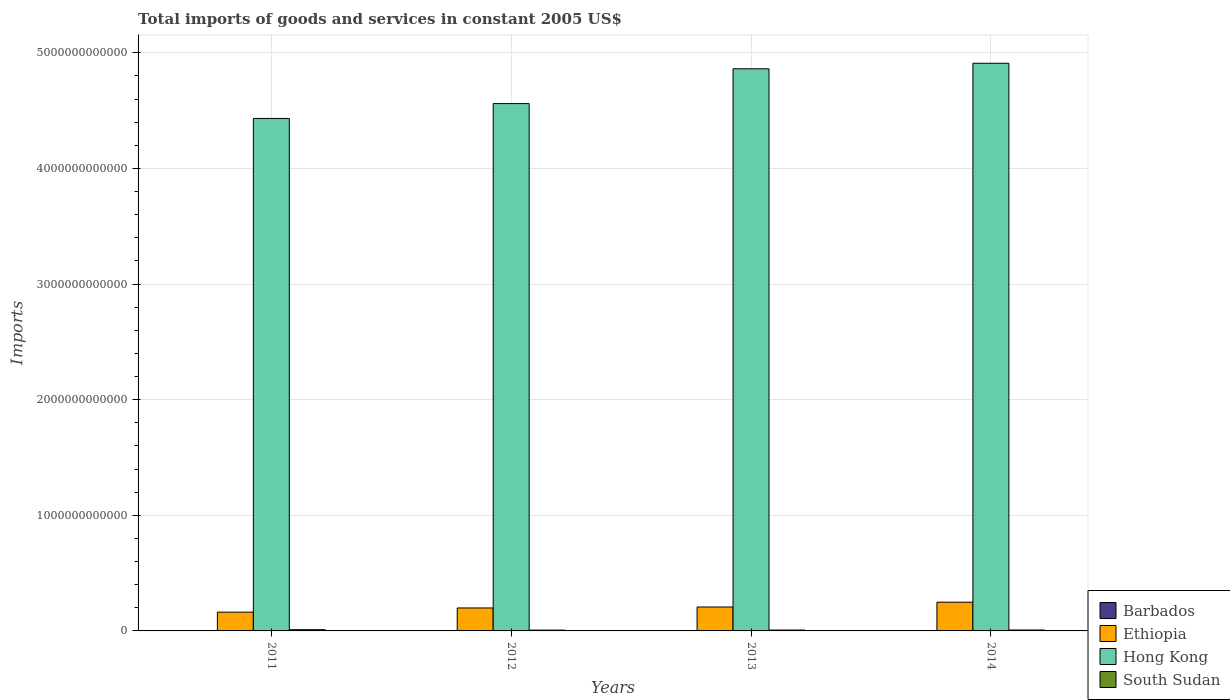How many different coloured bars are there?
Ensure brevity in your answer.  4. How many groups of bars are there?
Give a very brief answer. 4. Are the number of bars on each tick of the X-axis equal?
Ensure brevity in your answer.  Yes. What is the total imports of goods and services in Barbados in 2013?
Offer a terse response. 5.64e+08. Across all years, what is the maximum total imports of goods and services in Hong Kong?
Offer a terse response. 4.91e+12. Across all years, what is the minimum total imports of goods and services in Hong Kong?
Your answer should be very brief. 4.43e+12. What is the total total imports of goods and services in South Sudan in the graph?
Provide a succinct answer. 3.33e+1. What is the difference between the total imports of goods and services in South Sudan in 2012 and that in 2014?
Provide a succinct answer. -1.13e+09. What is the difference between the total imports of goods and services in Hong Kong in 2011 and the total imports of goods and services in Barbados in 2013?
Keep it short and to the point. 4.43e+12. What is the average total imports of goods and services in Barbados per year?
Your response must be concise. 5.76e+08. In the year 2011, what is the difference between the total imports of goods and services in Hong Kong and total imports of goods and services in Ethiopia?
Provide a short and direct response. 4.27e+12. What is the ratio of the total imports of goods and services in Barbados in 2011 to that in 2014?
Your answer should be very brief. 1.04. Is the total imports of goods and services in Ethiopia in 2011 less than that in 2013?
Provide a short and direct response. Yes. What is the difference between the highest and the second highest total imports of goods and services in South Sudan?
Make the answer very short. 2.64e+09. What is the difference between the highest and the lowest total imports of goods and services in Hong Kong?
Your answer should be compact. 4.77e+11. In how many years, is the total imports of goods and services in Barbados greater than the average total imports of goods and services in Barbados taken over all years?
Give a very brief answer. 1. Is the sum of the total imports of goods and services in Ethiopia in 2011 and 2014 greater than the maximum total imports of goods and services in South Sudan across all years?
Give a very brief answer. Yes. What does the 4th bar from the left in 2014 represents?
Provide a succinct answer. South Sudan. What does the 3rd bar from the right in 2012 represents?
Your answer should be compact. Ethiopia. How many bars are there?
Make the answer very short. 16. How many years are there in the graph?
Keep it short and to the point. 4. What is the difference between two consecutive major ticks on the Y-axis?
Make the answer very short. 1.00e+12. Does the graph contain grids?
Provide a short and direct response. Yes. What is the title of the graph?
Make the answer very short. Total imports of goods and services in constant 2005 US$. What is the label or title of the Y-axis?
Ensure brevity in your answer.  Imports. What is the Imports of Barbados in 2011?
Keep it short and to the point. 5.96e+08. What is the Imports of Ethiopia in 2011?
Make the answer very short. 1.62e+11. What is the Imports of Hong Kong in 2011?
Make the answer very short. 4.43e+12. What is the Imports in South Sudan in 2011?
Offer a very short reply. 1.07e+1. What is the Imports in Barbados in 2012?
Keep it short and to the point. 5.68e+08. What is the Imports in Ethiopia in 2012?
Keep it short and to the point. 1.99e+11. What is the Imports in Hong Kong in 2012?
Provide a short and direct response. 4.56e+12. What is the Imports of South Sudan in 2012?
Give a very brief answer. 6.91e+09. What is the Imports of Barbados in 2013?
Offer a very short reply. 5.64e+08. What is the Imports in Ethiopia in 2013?
Your answer should be compact. 2.07e+11. What is the Imports in Hong Kong in 2013?
Offer a very short reply. 4.86e+12. What is the Imports of South Sudan in 2013?
Make the answer very short. 7.65e+09. What is the Imports of Barbados in 2014?
Your answer should be very brief. 5.75e+08. What is the Imports of Ethiopia in 2014?
Your answer should be very brief. 2.49e+11. What is the Imports of Hong Kong in 2014?
Your answer should be compact. 4.91e+12. What is the Imports of South Sudan in 2014?
Your response must be concise. 8.04e+09. Across all years, what is the maximum Imports in Barbados?
Your answer should be compact. 5.96e+08. Across all years, what is the maximum Imports in Ethiopia?
Provide a succinct answer. 2.49e+11. Across all years, what is the maximum Imports of Hong Kong?
Keep it short and to the point. 4.91e+12. Across all years, what is the maximum Imports of South Sudan?
Make the answer very short. 1.07e+1. Across all years, what is the minimum Imports in Barbados?
Your response must be concise. 5.64e+08. Across all years, what is the minimum Imports in Ethiopia?
Provide a succinct answer. 1.62e+11. Across all years, what is the minimum Imports in Hong Kong?
Make the answer very short. 4.43e+12. Across all years, what is the minimum Imports in South Sudan?
Offer a terse response. 6.91e+09. What is the total Imports in Barbados in the graph?
Your response must be concise. 2.30e+09. What is the total Imports of Ethiopia in the graph?
Provide a short and direct response. 8.17e+11. What is the total Imports of Hong Kong in the graph?
Your answer should be compact. 1.88e+13. What is the total Imports of South Sudan in the graph?
Your response must be concise. 3.33e+1. What is the difference between the Imports of Barbados in 2011 and that in 2012?
Offer a very short reply. 2.80e+07. What is the difference between the Imports of Ethiopia in 2011 and that in 2012?
Your answer should be very brief. -3.61e+1. What is the difference between the Imports of Hong Kong in 2011 and that in 2012?
Give a very brief answer. -1.29e+11. What is the difference between the Imports of South Sudan in 2011 and that in 2012?
Make the answer very short. 3.76e+09. What is the difference between the Imports in Barbados in 2011 and that in 2013?
Offer a terse response. 3.20e+07. What is the difference between the Imports of Ethiopia in 2011 and that in 2013?
Your answer should be very brief. -4.44e+1. What is the difference between the Imports of Hong Kong in 2011 and that in 2013?
Ensure brevity in your answer.  -4.30e+11. What is the difference between the Imports in South Sudan in 2011 and that in 2013?
Your answer should be very brief. 3.02e+09. What is the difference between the Imports in Barbados in 2011 and that in 2014?
Provide a succinct answer. 2.10e+07. What is the difference between the Imports of Ethiopia in 2011 and that in 2014?
Your answer should be compact. -8.62e+1. What is the difference between the Imports of Hong Kong in 2011 and that in 2014?
Your answer should be very brief. -4.77e+11. What is the difference between the Imports in South Sudan in 2011 and that in 2014?
Your answer should be very brief. 2.64e+09. What is the difference between the Imports in Ethiopia in 2012 and that in 2013?
Offer a very short reply. -8.37e+09. What is the difference between the Imports of Hong Kong in 2012 and that in 2013?
Your answer should be compact. -3.01e+11. What is the difference between the Imports in South Sudan in 2012 and that in 2013?
Your answer should be very brief. -7.37e+08. What is the difference between the Imports in Barbados in 2012 and that in 2014?
Give a very brief answer. -7.00e+06. What is the difference between the Imports in Ethiopia in 2012 and that in 2014?
Provide a succinct answer. -5.01e+1. What is the difference between the Imports of Hong Kong in 2012 and that in 2014?
Make the answer very short. -3.49e+11. What is the difference between the Imports of South Sudan in 2012 and that in 2014?
Offer a terse response. -1.13e+09. What is the difference between the Imports in Barbados in 2013 and that in 2014?
Ensure brevity in your answer.  -1.10e+07. What is the difference between the Imports in Ethiopia in 2013 and that in 2014?
Offer a terse response. -4.18e+1. What is the difference between the Imports of Hong Kong in 2013 and that in 2014?
Your response must be concise. -4.78e+1. What is the difference between the Imports of South Sudan in 2013 and that in 2014?
Keep it short and to the point. -3.90e+08. What is the difference between the Imports in Barbados in 2011 and the Imports in Ethiopia in 2012?
Provide a succinct answer. -1.98e+11. What is the difference between the Imports of Barbados in 2011 and the Imports of Hong Kong in 2012?
Keep it short and to the point. -4.56e+12. What is the difference between the Imports in Barbados in 2011 and the Imports in South Sudan in 2012?
Keep it short and to the point. -6.31e+09. What is the difference between the Imports of Ethiopia in 2011 and the Imports of Hong Kong in 2012?
Ensure brevity in your answer.  -4.40e+12. What is the difference between the Imports in Ethiopia in 2011 and the Imports in South Sudan in 2012?
Your answer should be very brief. 1.56e+11. What is the difference between the Imports of Hong Kong in 2011 and the Imports of South Sudan in 2012?
Your response must be concise. 4.43e+12. What is the difference between the Imports of Barbados in 2011 and the Imports of Ethiopia in 2013?
Ensure brevity in your answer.  -2.06e+11. What is the difference between the Imports of Barbados in 2011 and the Imports of Hong Kong in 2013?
Your answer should be very brief. -4.86e+12. What is the difference between the Imports in Barbados in 2011 and the Imports in South Sudan in 2013?
Your response must be concise. -7.05e+09. What is the difference between the Imports of Ethiopia in 2011 and the Imports of Hong Kong in 2013?
Offer a very short reply. -4.70e+12. What is the difference between the Imports of Ethiopia in 2011 and the Imports of South Sudan in 2013?
Provide a succinct answer. 1.55e+11. What is the difference between the Imports in Hong Kong in 2011 and the Imports in South Sudan in 2013?
Your response must be concise. 4.42e+12. What is the difference between the Imports of Barbados in 2011 and the Imports of Ethiopia in 2014?
Your answer should be compact. -2.48e+11. What is the difference between the Imports in Barbados in 2011 and the Imports in Hong Kong in 2014?
Provide a short and direct response. -4.91e+12. What is the difference between the Imports of Barbados in 2011 and the Imports of South Sudan in 2014?
Your answer should be compact. -7.44e+09. What is the difference between the Imports in Ethiopia in 2011 and the Imports in Hong Kong in 2014?
Your response must be concise. -4.75e+12. What is the difference between the Imports of Ethiopia in 2011 and the Imports of South Sudan in 2014?
Offer a very short reply. 1.54e+11. What is the difference between the Imports of Hong Kong in 2011 and the Imports of South Sudan in 2014?
Ensure brevity in your answer.  4.42e+12. What is the difference between the Imports in Barbados in 2012 and the Imports in Ethiopia in 2013?
Give a very brief answer. -2.06e+11. What is the difference between the Imports in Barbados in 2012 and the Imports in Hong Kong in 2013?
Give a very brief answer. -4.86e+12. What is the difference between the Imports in Barbados in 2012 and the Imports in South Sudan in 2013?
Make the answer very short. -7.08e+09. What is the difference between the Imports of Ethiopia in 2012 and the Imports of Hong Kong in 2013?
Give a very brief answer. -4.66e+12. What is the difference between the Imports in Ethiopia in 2012 and the Imports in South Sudan in 2013?
Your answer should be very brief. 1.91e+11. What is the difference between the Imports in Hong Kong in 2012 and the Imports in South Sudan in 2013?
Your answer should be compact. 4.55e+12. What is the difference between the Imports in Barbados in 2012 and the Imports in Ethiopia in 2014?
Give a very brief answer. -2.48e+11. What is the difference between the Imports in Barbados in 2012 and the Imports in Hong Kong in 2014?
Your response must be concise. -4.91e+12. What is the difference between the Imports in Barbados in 2012 and the Imports in South Sudan in 2014?
Your answer should be compact. -7.47e+09. What is the difference between the Imports of Ethiopia in 2012 and the Imports of Hong Kong in 2014?
Your response must be concise. -4.71e+12. What is the difference between the Imports of Ethiopia in 2012 and the Imports of South Sudan in 2014?
Offer a very short reply. 1.91e+11. What is the difference between the Imports of Hong Kong in 2012 and the Imports of South Sudan in 2014?
Your answer should be very brief. 4.55e+12. What is the difference between the Imports in Barbados in 2013 and the Imports in Ethiopia in 2014?
Provide a succinct answer. -2.48e+11. What is the difference between the Imports in Barbados in 2013 and the Imports in Hong Kong in 2014?
Make the answer very short. -4.91e+12. What is the difference between the Imports of Barbados in 2013 and the Imports of South Sudan in 2014?
Offer a very short reply. -7.47e+09. What is the difference between the Imports of Ethiopia in 2013 and the Imports of Hong Kong in 2014?
Your response must be concise. -4.70e+12. What is the difference between the Imports of Ethiopia in 2013 and the Imports of South Sudan in 2014?
Keep it short and to the point. 1.99e+11. What is the difference between the Imports in Hong Kong in 2013 and the Imports in South Sudan in 2014?
Make the answer very short. 4.85e+12. What is the average Imports of Barbados per year?
Provide a short and direct response. 5.76e+08. What is the average Imports of Ethiopia per year?
Ensure brevity in your answer.  2.04e+11. What is the average Imports of Hong Kong per year?
Ensure brevity in your answer.  4.69e+12. What is the average Imports in South Sudan per year?
Keep it short and to the point. 8.32e+09. In the year 2011, what is the difference between the Imports of Barbados and Imports of Ethiopia?
Make the answer very short. -1.62e+11. In the year 2011, what is the difference between the Imports in Barbados and Imports in Hong Kong?
Offer a terse response. -4.43e+12. In the year 2011, what is the difference between the Imports of Barbados and Imports of South Sudan?
Your response must be concise. -1.01e+1. In the year 2011, what is the difference between the Imports of Ethiopia and Imports of Hong Kong?
Your answer should be very brief. -4.27e+12. In the year 2011, what is the difference between the Imports of Ethiopia and Imports of South Sudan?
Keep it short and to the point. 1.52e+11. In the year 2011, what is the difference between the Imports of Hong Kong and Imports of South Sudan?
Provide a succinct answer. 4.42e+12. In the year 2012, what is the difference between the Imports in Barbados and Imports in Ethiopia?
Ensure brevity in your answer.  -1.98e+11. In the year 2012, what is the difference between the Imports of Barbados and Imports of Hong Kong?
Your answer should be very brief. -4.56e+12. In the year 2012, what is the difference between the Imports in Barbados and Imports in South Sudan?
Ensure brevity in your answer.  -6.34e+09. In the year 2012, what is the difference between the Imports of Ethiopia and Imports of Hong Kong?
Your answer should be very brief. -4.36e+12. In the year 2012, what is the difference between the Imports in Ethiopia and Imports in South Sudan?
Your answer should be very brief. 1.92e+11. In the year 2012, what is the difference between the Imports of Hong Kong and Imports of South Sudan?
Your response must be concise. 4.55e+12. In the year 2013, what is the difference between the Imports of Barbados and Imports of Ethiopia?
Keep it short and to the point. -2.06e+11. In the year 2013, what is the difference between the Imports of Barbados and Imports of Hong Kong?
Provide a succinct answer. -4.86e+12. In the year 2013, what is the difference between the Imports of Barbados and Imports of South Sudan?
Provide a short and direct response. -7.08e+09. In the year 2013, what is the difference between the Imports of Ethiopia and Imports of Hong Kong?
Your answer should be compact. -4.66e+12. In the year 2013, what is the difference between the Imports of Ethiopia and Imports of South Sudan?
Ensure brevity in your answer.  1.99e+11. In the year 2013, what is the difference between the Imports in Hong Kong and Imports in South Sudan?
Ensure brevity in your answer.  4.85e+12. In the year 2014, what is the difference between the Imports of Barbados and Imports of Ethiopia?
Make the answer very short. -2.48e+11. In the year 2014, what is the difference between the Imports in Barbados and Imports in Hong Kong?
Offer a very short reply. -4.91e+12. In the year 2014, what is the difference between the Imports of Barbados and Imports of South Sudan?
Ensure brevity in your answer.  -7.46e+09. In the year 2014, what is the difference between the Imports of Ethiopia and Imports of Hong Kong?
Offer a terse response. -4.66e+12. In the year 2014, what is the difference between the Imports of Ethiopia and Imports of South Sudan?
Keep it short and to the point. 2.41e+11. In the year 2014, what is the difference between the Imports in Hong Kong and Imports in South Sudan?
Keep it short and to the point. 4.90e+12. What is the ratio of the Imports of Barbados in 2011 to that in 2012?
Give a very brief answer. 1.05. What is the ratio of the Imports in Ethiopia in 2011 to that in 2012?
Your answer should be very brief. 0.82. What is the ratio of the Imports of Hong Kong in 2011 to that in 2012?
Keep it short and to the point. 0.97. What is the ratio of the Imports of South Sudan in 2011 to that in 2012?
Offer a terse response. 1.54. What is the ratio of the Imports in Barbados in 2011 to that in 2013?
Keep it short and to the point. 1.06. What is the ratio of the Imports in Ethiopia in 2011 to that in 2013?
Provide a succinct answer. 0.79. What is the ratio of the Imports in Hong Kong in 2011 to that in 2013?
Offer a terse response. 0.91. What is the ratio of the Imports of South Sudan in 2011 to that in 2013?
Your response must be concise. 1.4. What is the ratio of the Imports of Barbados in 2011 to that in 2014?
Your response must be concise. 1.04. What is the ratio of the Imports of Ethiopia in 2011 to that in 2014?
Offer a terse response. 0.65. What is the ratio of the Imports in Hong Kong in 2011 to that in 2014?
Make the answer very short. 0.9. What is the ratio of the Imports in South Sudan in 2011 to that in 2014?
Your answer should be compact. 1.33. What is the ratio of the Imports of Barbados in 2012 to that in 2013?
Provide a short and direct response. 1.01. What is the ratio of the Imports of Ethiopia in 2012 to that in 2013?
Give a very brief answer. 0.96. What is the ratio of the Imports of Hong Kong in 2012 to that in 2013?
Offer a very short reply. 0.94. What is the ratio of the Imports in South Sudan in 2012 to that in 2013?
Offer a terse response. 0.9. What is the ratio of the Imports of Barbados in 2012 to that in 2014?
Give a very brief answer. 0.99. What is the ratio of the Imports of Ethiopia in 2012 to that in 2014?
Provide a succinct answer. 0.8. What is the ratio of the Imports of Hong Kong in 2012 to that in 2014?
Your response must be concise. 0.93. What is the ratio of the Imports of South Sudan in 2012 to that in 2014?
Offer a terse response. 0.86. What is the ratio of the Imports of Barbados in 2013 to that in 2014?
Keep it short and to the point. 0.98. What is the ratio of the Imports of Ethiopia in 2013 to that in 2014?
Your answer should be very brief. 0.83. What is the ratio of the Imports of Hong Kong in 2013 to that in 2014?
Your answer should be very brief. 0.99. What is the ratio of the Imports in South Sudan in 2013 to that in 2014?
Ensure brevity in your answer.  0.95. What is the difference between the highest and the second highest Imports of Barbados?
Offer a terse response. 2.10e+07. What is the difference between the highest and the second highest Imports of Ethiopia?
Provide a succinct answer. 4.18e+1. What is the difference between the highest and the second highest Imports in Hong Kong?
Give a very brief answer. 4.78e+1. What is the difference between the highest and the second highest Imports of South Sudan?
Your answer should be very brief. 2.64e+09. What is the difference between the highest and the lowest Imports of Barbados?
Provide a succinct answer. 3.20e+07. What is the difference between the highest and the lowest Imports in Ethiopia?
Ensure brevity in your answer.  8.62e+1. What is the difference between the highest and the lowest Imports in Hong Kong?
Your answer should be very brief. 4.77e+11. What is the difference between the highest and the lowest Imports in South Sudan?
Make the answer very short. 3.76e+09. 